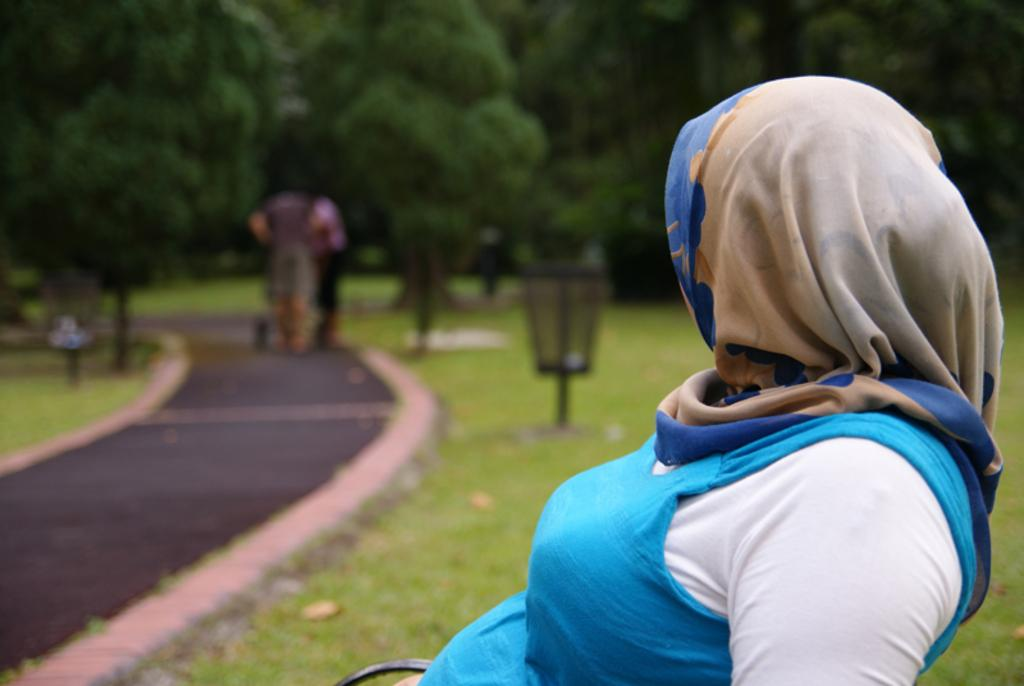Who is in the image? There is a woman in the image. What is the woman wearing? The woman is wearing a blue and white dress. What is the woman doing in the image? The woman is sitting on a bench. What can be seen in the background of the image? There are trees in the background of the image. What is visible in the foreground of the image? There is a path visible in the image. How many hands are visible in the image? There is no mention of hands in the provided facts, so we cannot determine the number of hands visible in the image. 